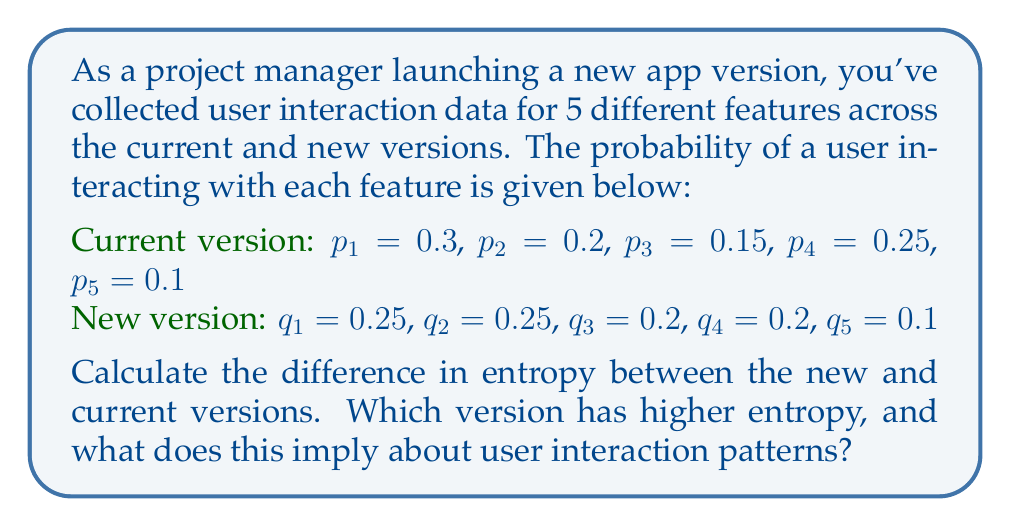Help me with this question. To solve this problem, we'll follow these steps:

1. Calculate the entropy for the current version
2. Calculate the entropy for the new version
3. Find the difference in entropy
4. Interpret the results

Step 1: Calculate the entropy for the current version

The entropy is given by the formula:
$$S = -k_B \sum_{i} p_i \ln(p_i)$$

Where $k_B$ is Boltzmann's constant, which we'll assume to be 1 for simplicity.

$$\begin{align}
S_{\text{current}} &= -(0.3 \ln(0.3) + 0.2 \ln(0.2) + 0.15 \ln(0.15) + 0.25 \ln(0.25) + 0.1 \ln(0.1)) \\
&\approx 1.5509
\end{align}$$

Step 2: Calculate the entropy for the new version

$$\begin{align}
S_{\text{new}} &= -(0.25 \ln(0.25) + 0.25 \ln(0.25) + 0.2 \ln(0.2) + 0.2 \ln(0.2) + 0.1 \ln(0.1)) \\
&\approx 1.5606
\end{align}$$

Step 3: Find the difference in entropy

$$\Delta S = S_{\text{new}} - S_{\text{current}} \approx 1.5606 - 1.5509 \approx 0.0097$$

Step 4: Interpret the results

The new version has a slightly higher entropy (by 0.0097). This implies that the user interaction patterns in the new version are more evenly distributed across the features, indicating a more balanced usage of the app's functionality.
Answer: $\Delta S \approx 0.0097$; New version has higher entropy, implying more balanced feature usage. 